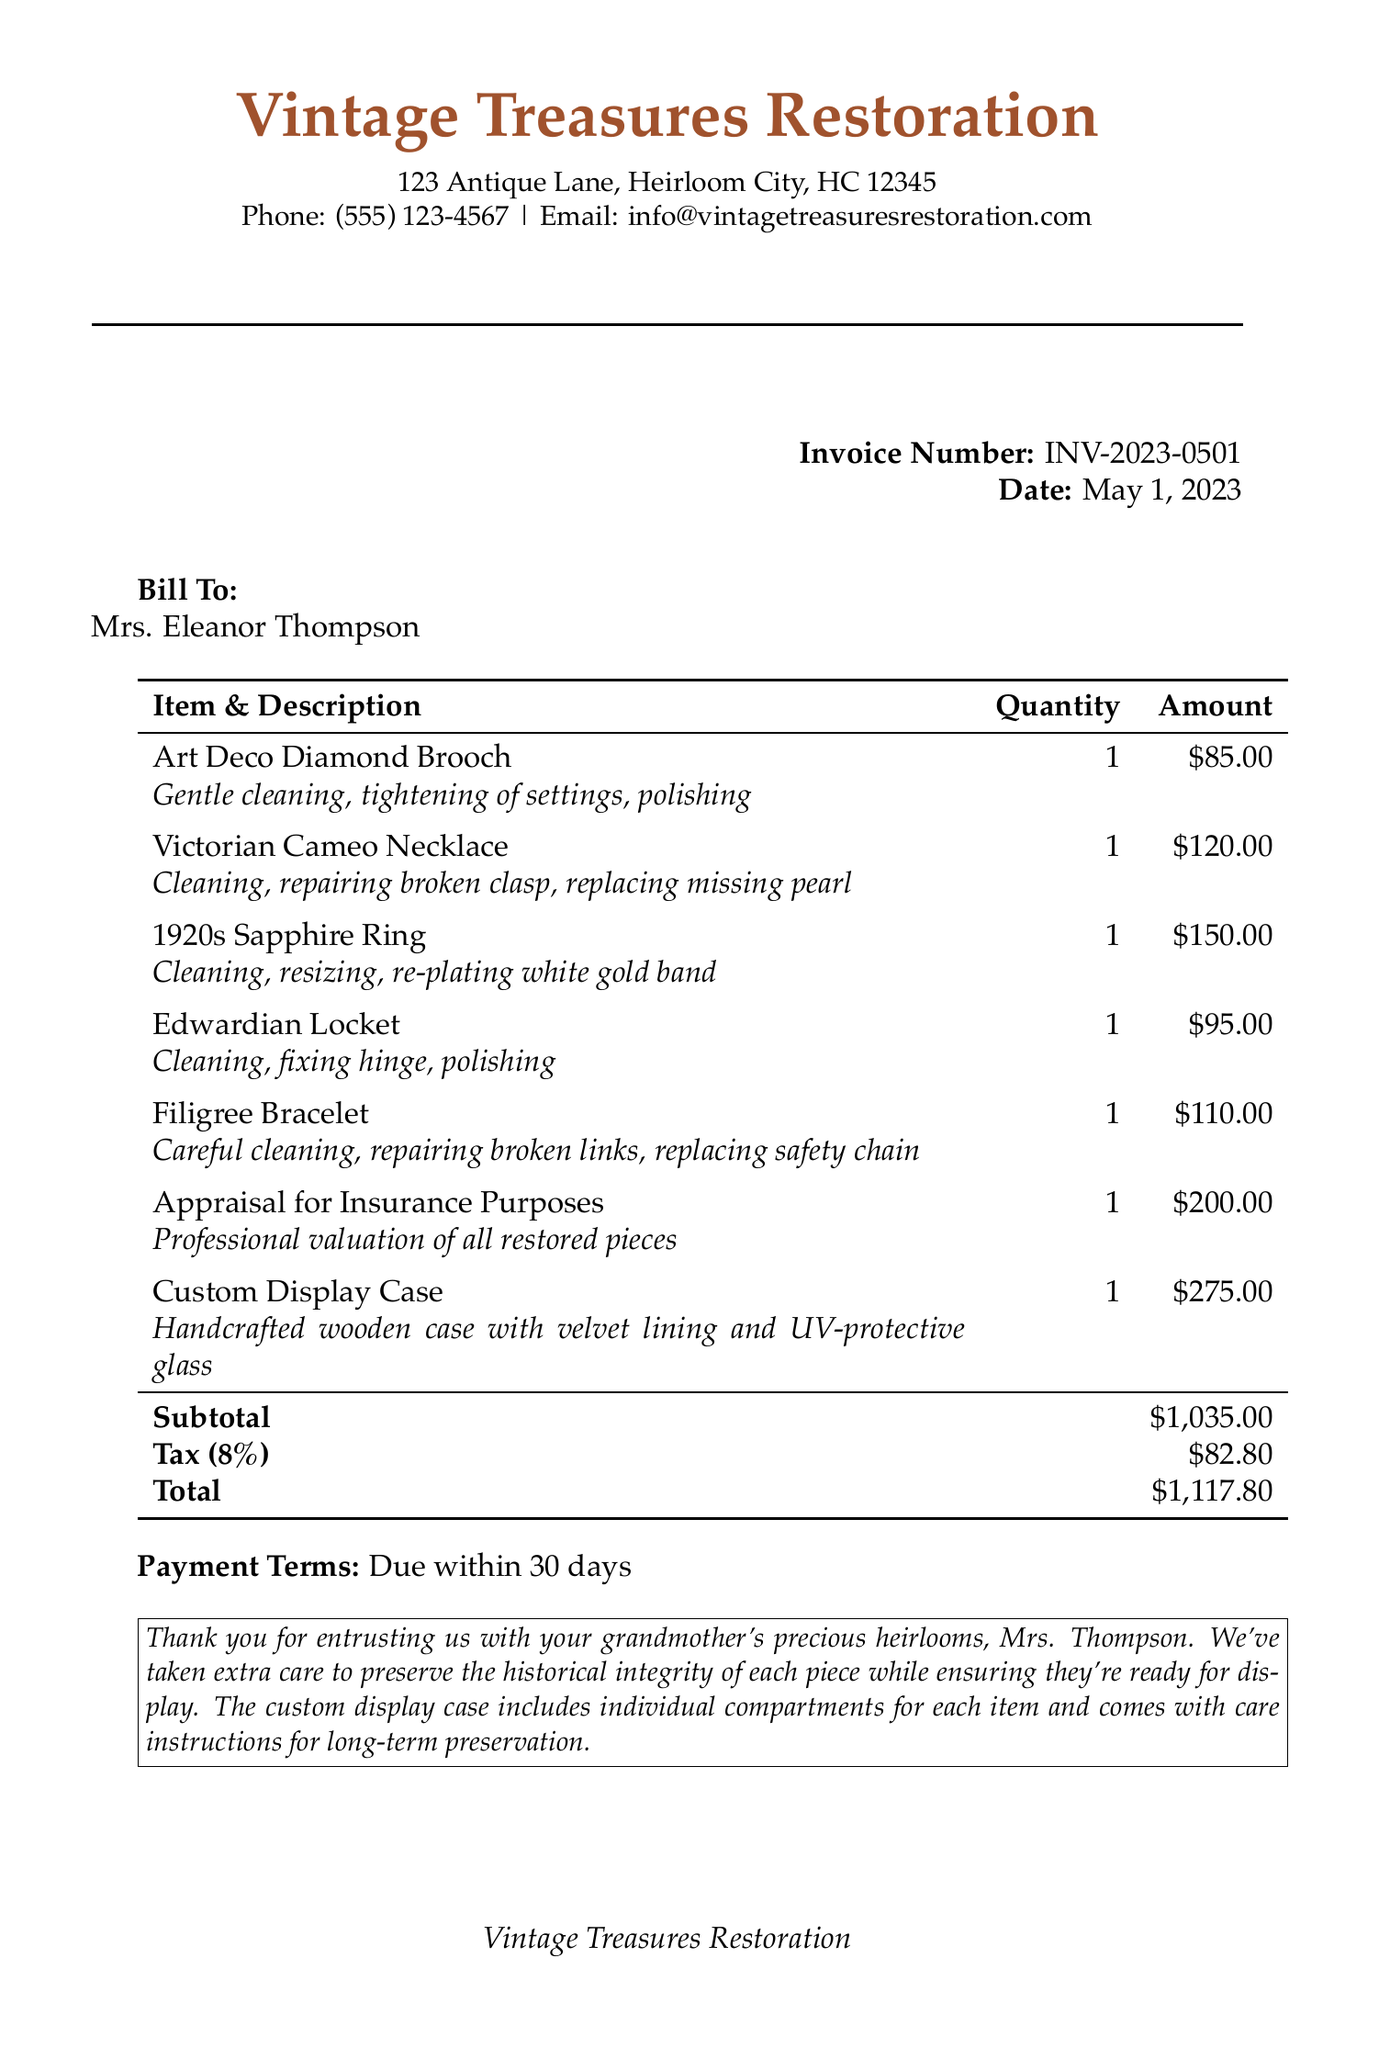What is the invoice number? The invoice number is a unique identifier for this document, listed prominently in the header.
Answer: INV-2023-0501 Who is the customer? The customer is the individual receiving the services, identified by name in the document.
Answer: Mrs. Eleanor Thompson What is the total amount due? The total amount is the culmination of the subtotal, tax, and any additional costs, indicated at the bottom of the invoice.
Answer: $1,117.80 How much was charged for the Victorian Cameo Necklace? This charge is specifically listed under the services provided and represents the cost for that item.
Answer: $120.00 What services were performed on the Edwardian Locket? The services mentioned are detailed descriptions of work done, which includes cleaning and fixing.
Answer: Cleaning, fixing hinge, polishing What is the tax rate applied to the invoice? The tax rate is specified in the invoice and is calculated based on the subtotal amount.
Answer: 8% What additional service was provided for insurance purposes? This is an extra service listed for which there is an additional charge.
Answer: Appraisal for Insurance Purposes What is included in the custom display case? The description outlines the features of the display case that was constructed for the jewelry items.
Answer: Handcrafted wooden case with velvet lining and UV-protective glass What is the payment term stated in the invoice? The payment term indicates the timeframe within which the customer is expected to pay the invoice amount.
Answer: Due within 30 days 